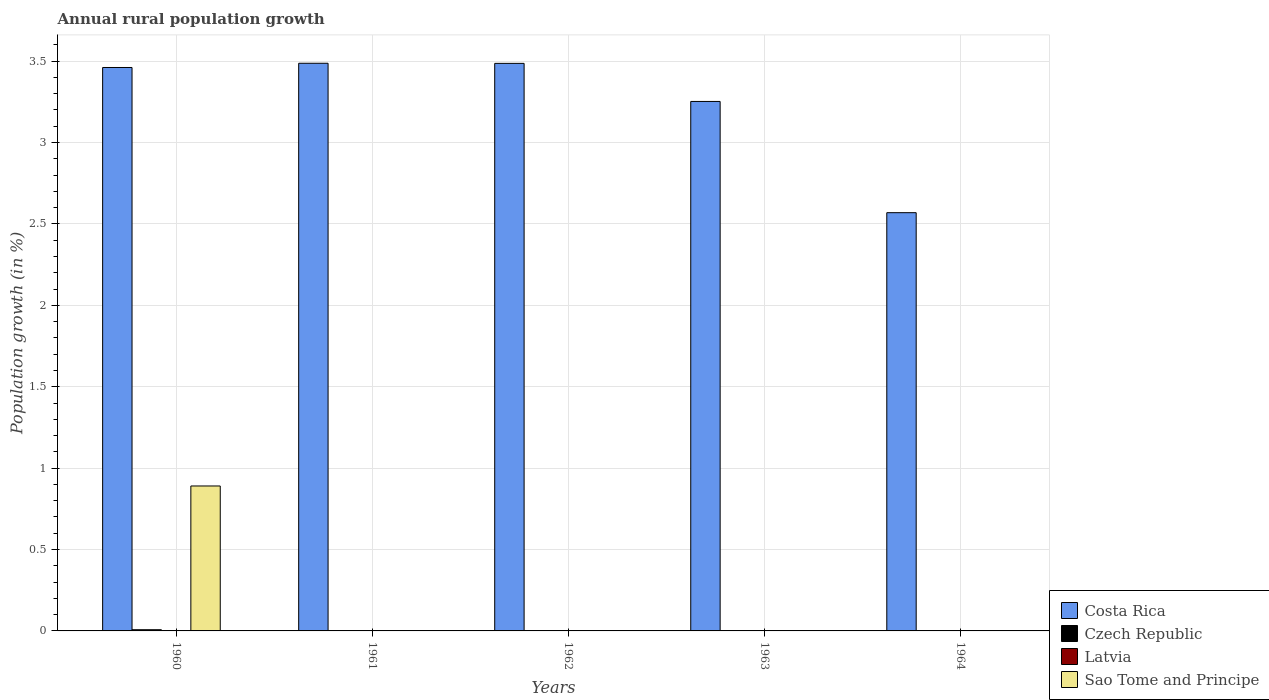How many different coloured bars are there?
Your answer should be very brief. 3. Are the number of bars per tick equal to the number of legend labels?
Your answer should be compact. No. Are the number of bars on each tick of the X-axis equal?
Offer a terse response. No. How many bars are there on the 4th tick from the left?
Provide a short and direct response. 1. In how many cases, is the number of bars for a given year not equal to the number of legend labels?
Provide a short and direct response. 5. What is the percentage of rural population growth in Latvia in 1960?
Ensure brevity in your answer.  0. Across all years, what is the maximum percentage of rural population growth in Sao Tome and Principe?
Give a very brief answer. 0.89. Across all years, what is the minimum percentage of rural population growth in Latvia?
Give a very brief answer. 0. In which year was the percentage of rural population growth in Czech Republic maximum?
Ensure brevity in your answer.  1960. What is the total percentage of rural population growth in Sao Tome and Principe in the graph?
Make the answer very short. 0.89. What is the difference between the percentage of rural population growth in Costa Rica in 1962 and that in 1963?
Make the answer very short. 0.23. What is the difference between the percentage of rural population growth in Costa Rica in 1963 and the percentage of rural population growth in Latvia in 1964?
Your answer should be very brief. 3.25. What is the average percentage of rural population growth in Sao Tome and Principe per year?
Your answer should be compact. 0.18. In the year 1960, what is the difference between the percentage of rural population growth in Costa Rica and percentage of rural population growth in Czech Republic?
Give a very brief answer. 3.45. In how many years, is the percentage of rural population growth in Latvia greater than 1.8 %?
Ensure brevity in your answer.  0. What is the ratio of the percentage of rural population growth in Costa Rica in 1961 to that in 1963?
Provide a succinct answer. 1.07. What is the difference between the highest and the second highest percentage of rural population growth in Costa Rica?
Offer a terse response. 0. What is the difference between the highest and the lowest percentage of rural population growth in Czech Republic?
Ensure brevity in your answer.  0.01. In how many years, is the percentage of rural population growth in Czech Republic greater than the average percentage of rural population growth in Czech Republic taken over all years?
Your answer should be compact. 1. Is the sum of the percentage of rural population growth in Costa Rica in 1961 and 1964 greater than the maximum percentage of rural population growth in Latvia across all years?
Your answer should be very brief. Yes. Is it the case that in every year, the sum of the percentage of rural population growth in Latvia and percentage of rural population growth in Czech Republic is greater than the percentage of rural population growth in Costa Rica?
Provide a short and direct response. No. How many bars are there?
Provide a succinct answer. 7. How many years are there in the graph?
Provide a short and direct response. 5. What is the difference between two consecutive major ticks on the Y-axis?
Your response must be concise. 0.5. Are the values on the major ticks of Y-axis written in scientific E-notation?
Ensure brevity in your answer.  No. Where does the legend appear in the graph?
Keep it short and to the point. Bottom right. What is the title of the graph?
Ensure brevity in your answer.  Annual rural population growth. Does "Canada" appear as one of the legend labels in the graph?
Keep it short and to the point. No. What is the label or title of the X-axis?
Provide a short and direct response. Years. What is the label or title of the Y-axis?
Ensure brevity in your answer.  Population growth (in %). What is the Population growth (in %) of Costa Rica in 1960?
Keep it short and to the point. 3.46. What is the Population growth (in %) of Czech Republic in 1960?
Offer a terse response. 0.01. What is the Population growth (in %) of Latvia in 1960?
Make the answer very short. 0. What is the Population growth (in %) in Sao Tome and Principe in 1960?
Give a very brief answer. 0.89. What is the Population growth (in %) of Costa Rica in 1961?
Your answer should be very brief. 3.49. What is the Population growth (in %) in Czech Republic in 1961?
Ensure brevity in your answer.  0. What is the Population growth (in %) in Costa Rica in 1962?
Your answer should be compact. 3.49. What is the Population growth (in %) of Czech Republic in 1962?
Ensure brevity in your answer.  0. What is the Population growth (in %) in Latvia in 1962?
Your answer should be very brief. 0. What is the Population growth (in %) of Costa Rica in 1963?
Make the answer very short. 3.25. What is the Population growth (in %) in Czech Republic in 1963?
Your answer should be compact. 0. What is the Population growth (in %) of Sao Tome and Principe in 1963?
Your response must be concise. 0. What is the Population growth (in %) in Costa Rica in 1964?
Your response must be concise. 2.57. What is the Population growth (in %) in Czech Republic in 1964?
Your response must be concise. 0. Across all years, what is the maximum Population growth (in %) in Costa Rica?
Provide a succinct answer. 3.49. Across all years, what is the maximum Population growth (in %) of Czech Republic?
Offer a terse response. 0.01. Across all years, what is the maximum Population growth (in %) in Sao Tome and Principe?
Ensure brevity in your answer.  0.89. Across all years, what is the minimum Population growth (in %) of Costa Rica?
Provide a short and direct response. 2.57. What is the total Population growth (in %) in Costa Rica in the graph?
Offer a very short reply. 16.26. What is the total Population growth (in %) in Czech Republic in the graph?
Offer a very short reply. 0.01. What is the total Population growth (in %) of Latvia in the graph?
Make the answer very short. 0. What is the total Population growth (in %) in Sao Tome and Principe in the graph?
Offer a terse response. 0.89. What is the difference between the Population growth (in %) of Costa Rica in 1960 and that in 1961?
Offer a very short reply. -0.03. What is the difference between the Population growth (in %) in Costa Rica in 1960 and that in 1962?
Provide a short and direct response. -0.03. What is the difference between the Population growth (in %) in Costa Rica in 1960 and that in 1963?
Keep it short and to the point. 0.21. What is the difference between the Population growth (in %) in Costa Rica in 1960 and that in 1964?
Provide a short and direct response. 0.89. What is the difference between the Population growth (in %) in Costa Rica in 1961 and that in 1962?
Provide a succinct answer. 0. What is the difference between the Population growth (in %) in Costa Rica in 1961 and that in 1963?
Provide a short and direct response. 0.23. What is the difference between the Population growth (in %) in Costa Rica in 1961 and that in 1964?
Keep it short and to the point. 0.92. What is the difference between the Population growth (in %) of Costa Rica in 1962 and that in 1963?
Give a very brief answer. 0.23. What is the difference between the Population growth (in %) of Costa Rica in 1962 and that in 1964?
Ensure brevity in your answer.  0.92. What is the difference between the Population growth (in %) in Costa Rica in 1963 and that in 1964?
Offer a very short reply. 0.68. What is the average Population growth (in %) of Costa Rica per year?
Offer a terse response. 3.25. What is the average Population growth (in %) of Czech Republic per year?
Keep it short and to the point. 0. What is the average Population growth (in %) of Sao Tome and Principe per year?
Offer a terse response. 0.18. In the year 1960, what is the difference between the Population growth (in %) of Costa Rica and Population growth (in %) of Czech Republic?
Offer a terse response. 3.45. In the year 1960, what is the difference between the Population growth (in %) in Costa Rica and Population growth (in %) in Sao Tome and Principe?
Offer a very short reply. 2.57. In the year 1960, what is the difference between the Population growth (in %) of Czech Republic and Population growth (in %) of Sao Tome and Principe?
Offer a very short reply. -0.88. What is the ratio of the Population growth (in %) in Costa Rica in 1960 to that in 1961?
Make the answer very short. 0.99. What is the ratio of the Population growth (in %) of Costa Rica in 1960 to that in 1963?
Offer a terse response. 1.06. What is the ratio of the Population growth (in %) in Costa Rica in 1960 to that in 1964?
Make the answer very short. 1.35. What is the ratio of the Population growth (in %) in Costa Rica in 1961 to that in 1962?
Ensure brevity in your answer.  1. What is the ratio of the Population growth (in %) of Costa Rica in 1961 to that in 1963?
Your answer should be compact. 1.07. What is the ratio of the Population growth (in %) of Costa Rica in 1961 to that in 1964?
Ensure brevity in your answer.  1.36. What is the ratio of the Population growth (in %) of Costa Rica in 1962 to that in 1963?
Offer a terse response. 1.07. What is the ratio of the Population growth (in %) in Costa Rica in 1962 to that in 1964?
Give a very brief answer. 1.36. What is the ratio of the Population growth (in %) of Costa Rica in 1963 to that in 1964?
Your response must be concise. 1.27. What is the difference between the highest and the second highest Population growth (in %) in Costa Rica?
Provide a succinct answer. 0. What is the difference between the highest and the lowest Population growth (in %) of Costa Rica?
Keep it short and to the point. 0.92. What is the difference between the highest and the lowest Population growth (in %) of Czech Republic?
Give a very brief answer. 0.01. What is the difference between the highest and the lowest Population growth (in %) in Sao Tome and Principe?
Give a very brief answer. 0.89. 